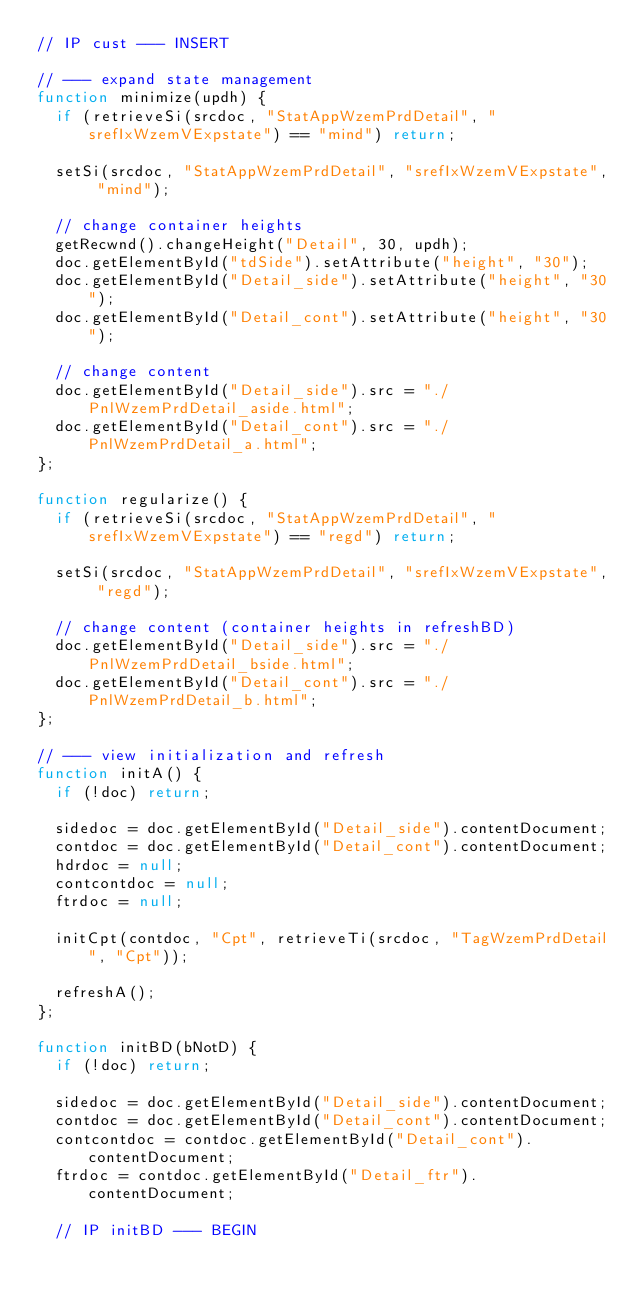<code> <loc_0><loc_0><loc_500><loc_500><_JavaScript_>// IP cust --- INSERT

// --- expand state management
function minimize(updh) {
	if (retrieveSi(srcdoc, "StatAppWzemPrdDetail", "srefIxWzemVExpstate") == "mind") return;

	setSi(srcdoc, "StatAppWzemPrdDetail", "srefIxWzemVExpstate", "mind");

	// change container heights
	getRecwnd().changeHeight("Detail", 30, updh);
	doc.getElementById("tdSide").setAttribute("height", "30");
	doc.getElementById("Detail_side").setAttribute("height", "30");
	doc.getElementById("Detail_cont").setAttribute("height", "30");

	// change content
	doc.getElementById("Detail_side").src = "./PnlWzemPrdDetail_aside.html";
	doc.getElementById("Detail_cont").src = "./PnlWzemPrdDetail_a.html";
};

function regularize() {
	if (retrieveSi(srcdoc, "StatAppWzemPrdDetail", "srefIxWzemVExpstate") == "regd") return;

	setSi(srcdoc, "StatAppWzemPrdDetail", "srefIxWzemVExpstate", "regd");

	// change content (container heights in refreshBD)
	doc.getElementById("Detail_side").src = "./PnlWzemPrdDetail_bside.html";
	doc.getElementById("Detail_cont").src = "./PnlWzemPrdDetail_b.html";
};

// --- view initialization and refresh
function initA() {
	if (!doc) return;

	sidedoc = doc.getElementById("Detail_side").contentDocument;
	contdoc = doc.getElementById("Detail_cont").contentDocument;
	hdrdoc = null;
	contcontdoc = null;
	ftrdoc = null;

	initCpt(contdoc, "Cpt", retrieveTi(srcdoc, "TagWzemPrdDetail", "Cpt"));

	refreshA();
};

function initBD(bNotD) {
	if (!doc) return;

	sidedoc = doc.getElementById("Detail_side").contentDocument;
	contdoc = doc.getElementById("Detail_cont").contentDocument;
	contcontdoc = contdoc.getElementById("Detail_cont").contentDocument;
	ftrdoc = contdoc.getElementById("Detail_ftr").contentDocument;

	// IP initBD --- BEGIN</code> 